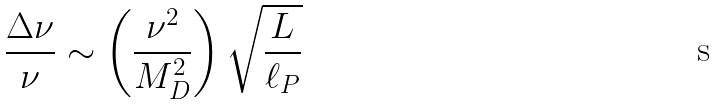Convert formula to latex. <formula><loc_0><loc_0><loc_500><loc_500>\frac { \Delta \nu } { \nu } \sim \left ( \frac { \nu ^ { 2 } } { M _ { D } ^ { 2 } } \right ) \sqrt { \frac { L } { \ell _ { P } } }</formula> 